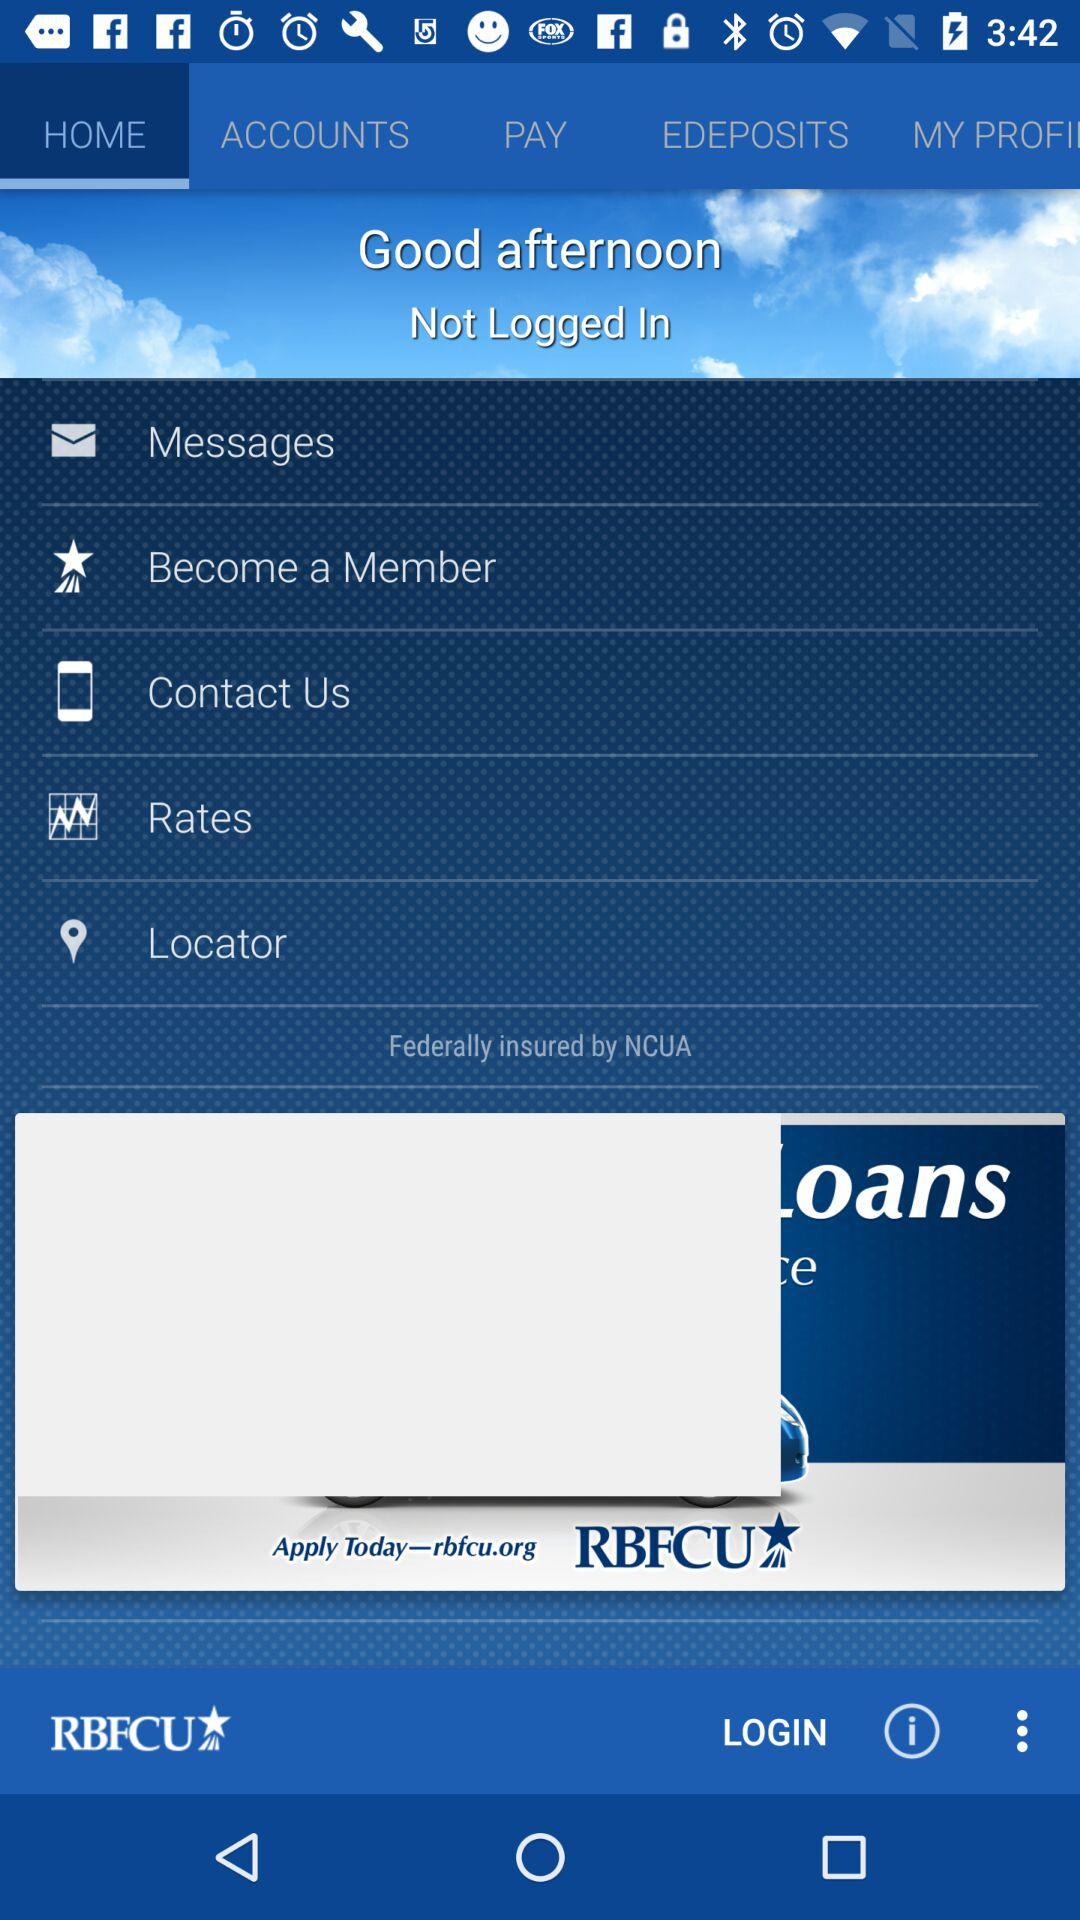At which site can we apply today? You can apply today at rbfcu.org. 